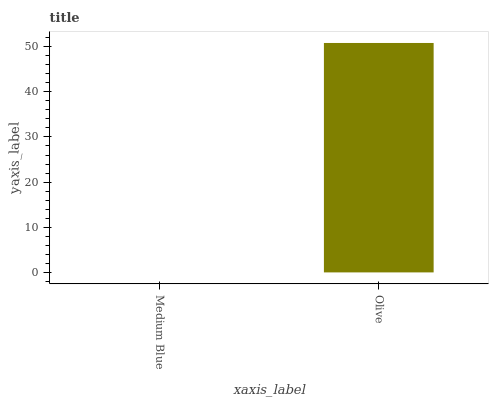Is Medium Blue the minimum?
Answer yes or no. Yes. Is Olive the maximum?
Answer yes or no. Yes. Is Olive the minimum?
Answer yes or no. No. Is Olive greater than Medium Blue?
Answer yes or no. Yes. Is Medium Blue less than Olive?
Answer yes or no. Yes. Is Medium Blue greater than Olive?
Answer yes or no. No. Is Olive less than Medium Blue?
Answer yes or no. No. Is Olive the high median?
Answer yes or no. Yes. Is Medium Blue the low median?
Answer yes or no. Yes. Is Medium Blue the high median?
Answer yes or no. No. Is Olive the low median?
Answer yes or no. No. 